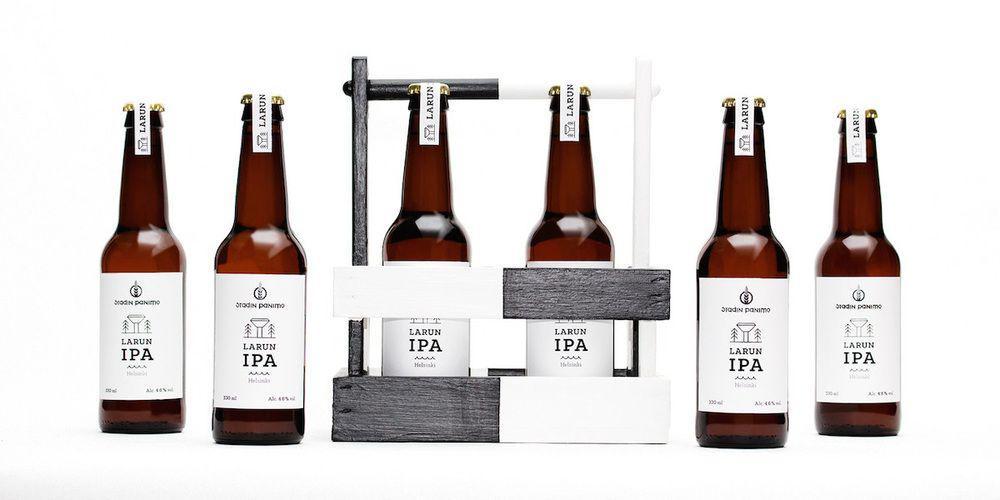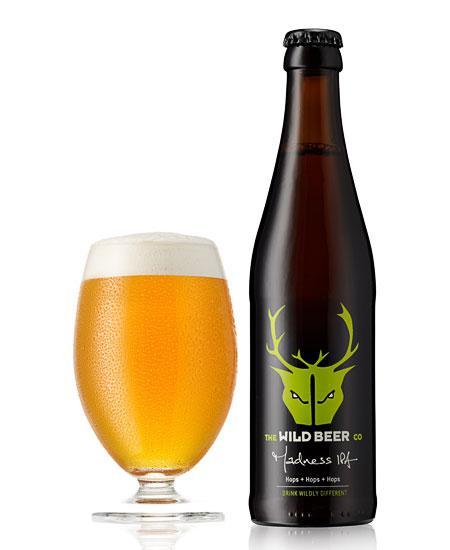The first image is the image on the left, the second image is the image on the right. Evaluate the accuracy of this statement regarding the images: "One of the images shows a glass next to a bottle of beer and the other image shows a row of beer bottles.". Is it true? Answer yes or no. Yes. 